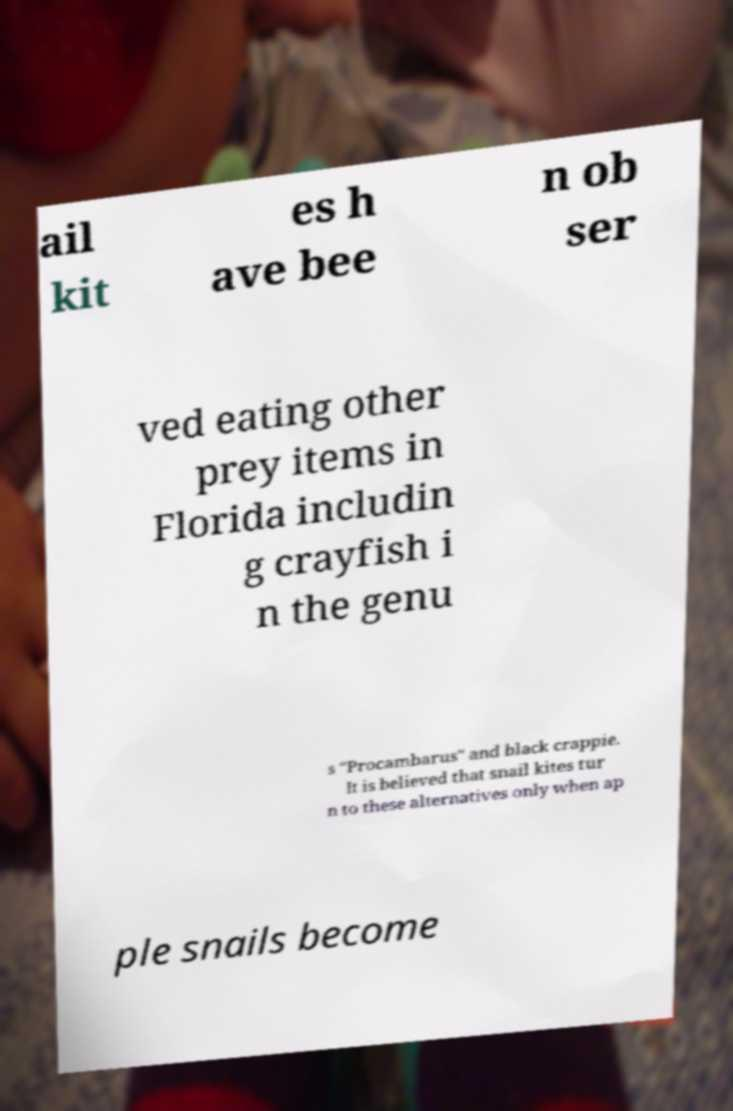What messages or text are displayed in this image? I need them in a readable, typed format. ail kit es h ave bee n ob ser ved eating other prey items in Florida includin g crayfish i n the genu s "Procambarus" and black crappie. It is believed that snail kites tur n to these alternatives only when ap ple snails become 